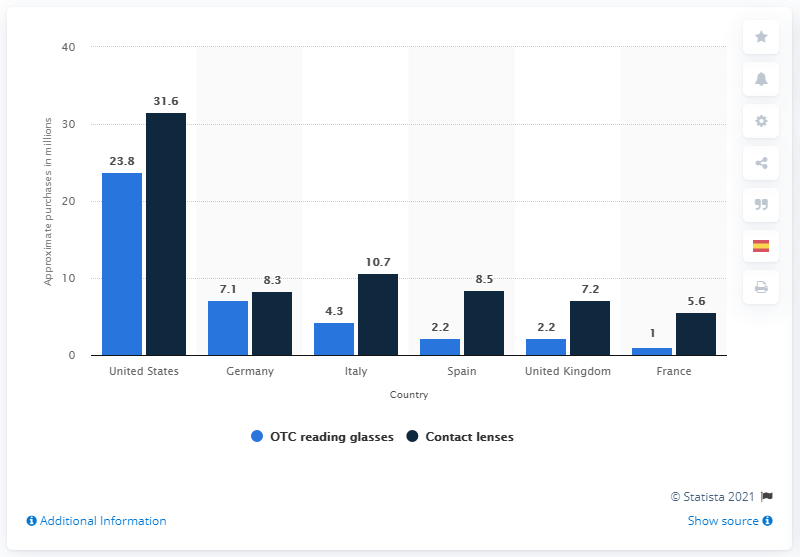List a handful of essential elements in this visual. In 2013, 7.1 million units of OTC readers were purchased in Germany. In 2013, a total of 7.1 units of OTC readers were purchased in Germany. According to the data, a total of 16.8 million OTC reading glasses were sold outside the US. The United States is the country that purchases the most products in the chart. 